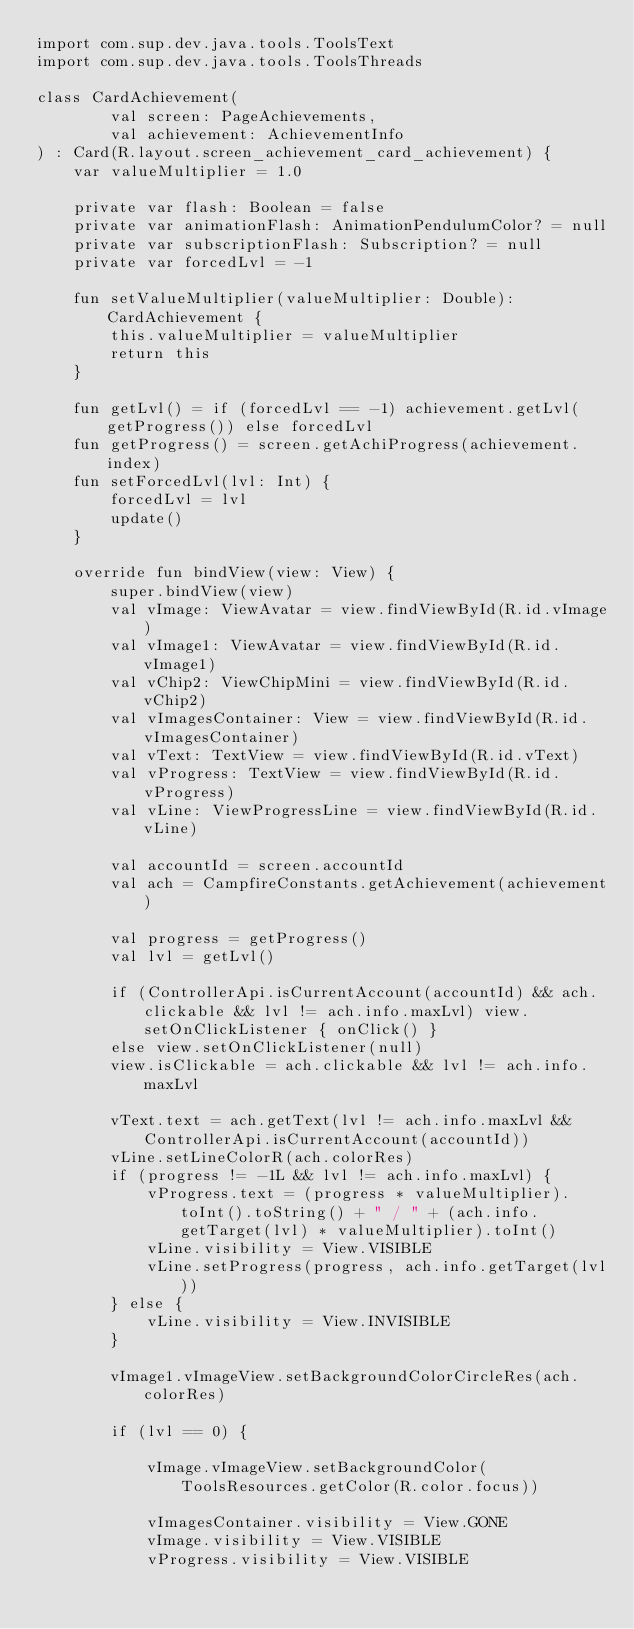<code> <loc_0><loc_0><loc_500><loc_500><_Kotlin_>import com.sup.dev.java.tools.ToolsText
import com.sup.dev.java.tools.ToolsThreads

class CardAchievement(
        val screen: PageAchievements,
        val achievement: AchievementInfo
) : Card(R.layout.screen_achievement_card_achievement) {
    var valueMultiplier = 1.0

    private var flash: Boolean = false
    private var animationFlash: AnimationPendulumColor? = null
    private var subscriptionFlash: Subscription? = null
    private var forcedLvl = -1

    fun setValueMultiplier(valueMultiplier: Double): CardAchievement {
        this.valueMultiplier = valueMultiplier
        return this
    }

    fun getLvl() = if (forcedLvl == -1) achievement.getLvl(getProgress()) else forcedLvl
    fun getProgress() = screen.getAchiProgress(achievement.index)
    fun setForcedLvl(lvl: Int) {
        forcedLvl = lvl
        update()
    }

    override fun bindView(view: View) {
        super.bindView(view)
        val vImage: ViewAvatar = view.findViewById(R.id.vImage)
        val vImage1: ViewAvatar = view.findViewById(R.id.vImage1)
        val vChip2: ViewChipMini = view.findViewById(R.id.vChip2)
        val vImagesContainer: View = view.findViewById(R.id.vImagesContainer)
        val vText: TextView = view.findViewById(R.id.vText)
        val vProgress: TextView = view.findViewById(R.id.vProgress)
        val vLine: ViewProgressLine = view.findViewById(R.id.vLine)

        val accountId = screen.accountId
        val ach = CampfireConstants.getAchievement(achievement)

        val progress = getProgress()
        val lvl = getLvl()

        if (ControllerApi.isCurrentAccount(accountId) && ach.clickable && lvl != ach.info.maxLvl) view.setOnClickListener { onClick() }
        else view.setOnClickListener(null)
        view.isClickable = ach.clickable && lvl != ach.info.maxLvl

        vText.text = ach.getText(lvl != ach.info.maxLvl && ControllerApi.isCurrentAccount(accountId))
        vLine.setLineColorR(ach.colorRes)
        if (progress != -1L && lvl != ach.info.maxLvl) {
            vProgress.text = (progress * valueMultiplier).toInt().toString() + " / " + (ach.info.getTarget(lvl) * valueMultiplier).toInt()
            vLine.visibility = View.VISIBLE
            vLine.setProgress(progress, ach.info.getTarget(lvl))
        } else {
            vLine.visibility = View.INVISIBLE
        }

        vImage1.vImageView.setBackgroundColorCircleRes(ach.colorRes)

        if (lvl == 0) {

            vImage.vImageView.setBackgroundColor(ToolsResources.getColor(R.color.focus))

            vImagesContainer.visibility = View.GONE
            vImage.visibility = View.VISIBLE
            vProgress.visibility = View.VISIBLE
</code> 